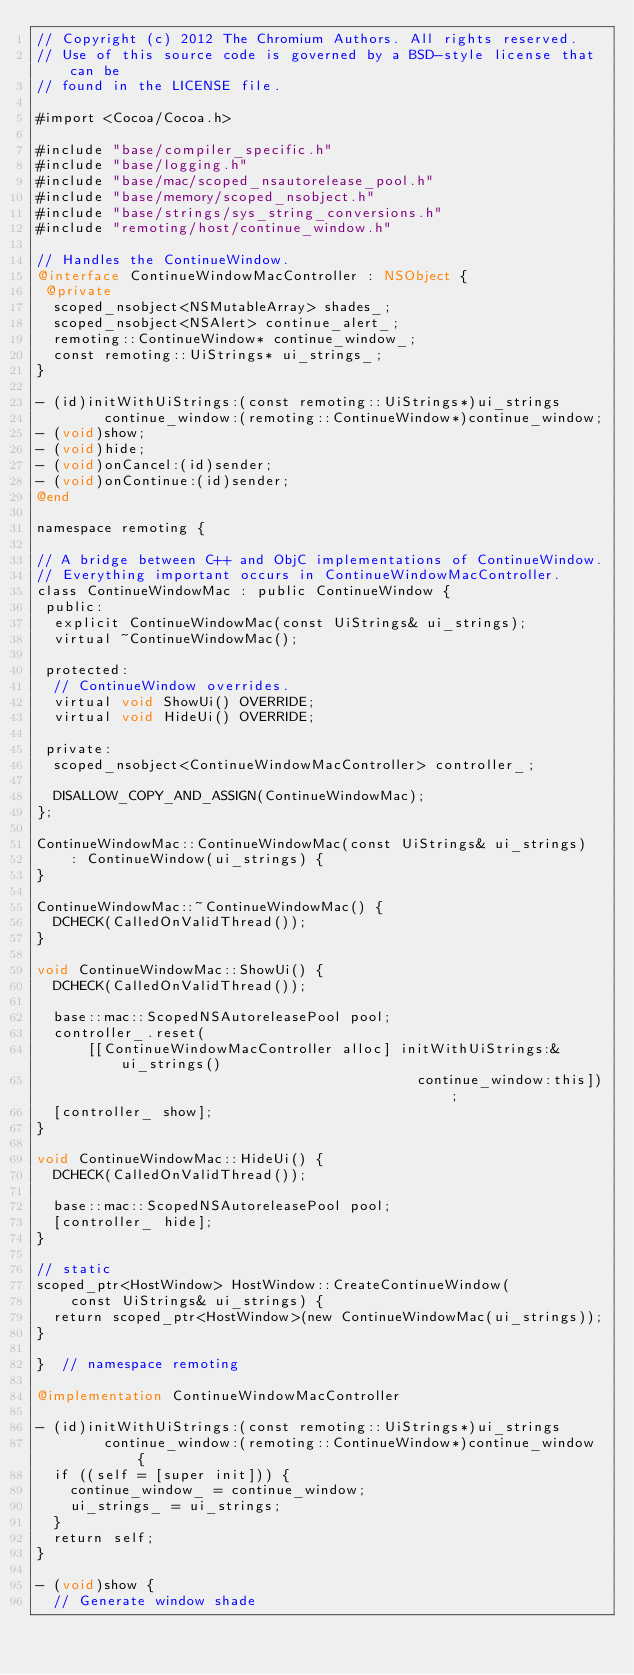<code> <loc_0><loc_0><loc_500><loc_500><_ObjectiveC_>// Copyright (c) 2012 The Chromium Authors. All rights reserved.
// Use of this source code is governed by a BSD-style license that can be
// found in the LICENSE file.

#import <Cocoa/Cocoa.h>

#include "base/compiler_specific.h"
#include "base/logging.h"
#include "base/mac/scoped_nsautorelease_pool.h"
#include "base/memory/scoped_nsobject.h"
#include "base/strings/sys_string_conversions.h"
#include "remoting/host/continue_window.h"

// Handles the ContinueWindow.
@interface ContinueWindowMacController : NSObject {
 @private
  scoped_nsobject<NSMutableArray> shades_;
  scoped_nsobject<NSAlert> continue_alert_;
  remoting::ContinueWindow* continue_window_;
  const remoting::UiStrings* ui_strings_;
}

- (id)initWithUiStrings:(const remoting::UiStrings*)ui_strings
        continue_window:(remoting::ContinueWindow*)continue_window;
- (void)show;
- (void)hide;
- (void)onCancel:(id)sender;
- (void)onContinue:(id)sender;
@end

namespace remoting {

// A bridge between C++ and ObjC implementations of ContinueWindow.
// Everything important occurs in ContinueWindowMacController.
class ContinueWindowMac : public ContinueWindow {
 public:
  explicit ContinueWindowMac(const UiStrings& ui_strings);
  virtual ~ContinueWindowMac();

 protected:
  // ContinueWindow overrides.
  virtual void ShowUi() OVERRIDE;
  virtual void HideUi() OVERRIDE;

 private:
  scoped_nsobject<ContinueWindowMacController> controller_;

  DISALLOW_COPY_AND_ASSIGN(ContinueWindowMac);
};

ContinueWindowMac::ContinueWindowMac(const UiStrings& ui_strings)
    : ContinueWindow(ui_strings) {
}

ContinueWindowMac::~ContinueWindowMac() {
  DCHECK(CalledOnValidThread());
}

void ContinueWindowMac::ShowUi() {
  DCHECK(CalledOnValidThread());

  base::mac::ScopedNSAutoreleasePool pool;
  controller_.reset(
      [[ContinueWindowMacController alloc] initWithUiStrings:&ui_strings()
                                             continue_window:this]);
  [controller_ show];
}

void ContinueWindowMac::HideUi() {
  DCHECK(CalledOnValidThread());

  base::mac::ScopedNSAutoreleasePool pool;
  [controller_ hide];
}

// static
scoped_ptr<HostWindow> HostWindow::CreateContinueWindow(
    const UiStrings& ui_strings) {
  return scoped_ptr<HostWindow>(new ContinueWindowMac(ui_strings));
}

}  // namespace remoting

@implementation ContinueWindowMacController

- (id)initWithUiStrings:(const remoting::UiStrings*)ui_strings
        continue_window:(remoting::ContinueWindow*)continue_window {
  if ((self = [super init])) {
    continue_window_ = continue_window;
    ui_strings_ = ui_strings;
  }
  return self;
}

- (void)show {
  // Generate window shade</code> 